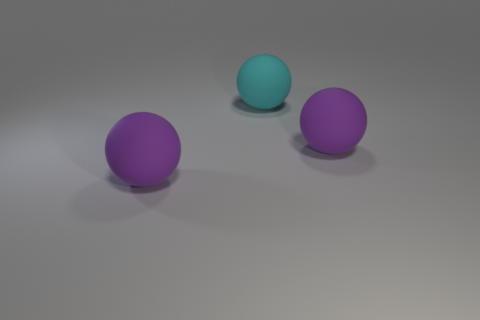There is a sphere left of the big cyan object; what color is it?
Give a very brief answer. Purple. Are there any purple matte objects of the same shape as the cyan thing?
Offer a very short reply. Yes. How many yellow things are either rubber spheres or metal balls?
Provide a succinct answer. 0. Are there any cyan rubber balls that have the same size as the cyan thing?
Make the answer very short. No. How many purple spheres are there?
Keep it short and to the point. 2. How many big things are either purple rubber balls or yellow shiny balls?
Keep it short and to the point. 2. There is a large ball left of the cyan thing that is to the left of the matte thing that is on the right side of the cyan rubber thing; what color is it?
Provide a succinct answer. Purple. What number of matte objects are either large cyan balls or large spheres?
Your answer should be compact. 3. There is a rubber thing that is to the left of the cyan matte sphere; is its color the same as the large rubber thing that is to the right of the cyan thing?
Give a very brief answer. Yes. Is there anything else that is made of the same material as the cyan ball?
Keep it short and to the point. Yes. 